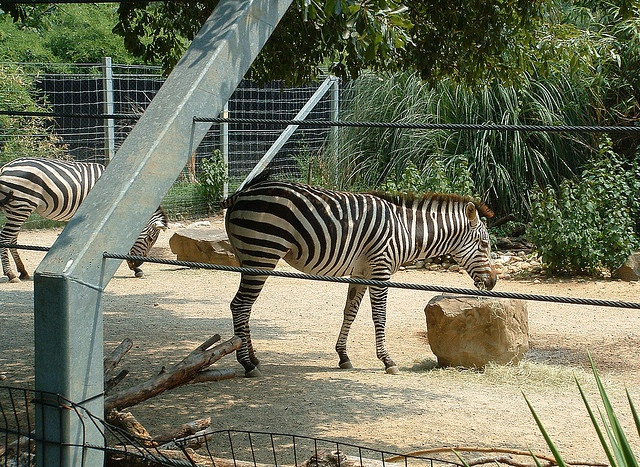Describe the objects in this image and their specific colors. I can see zebra in black, gray, darkgreen, and darkgray tones and zebra in black, gray, ivory, and darkgray tones in this image. 